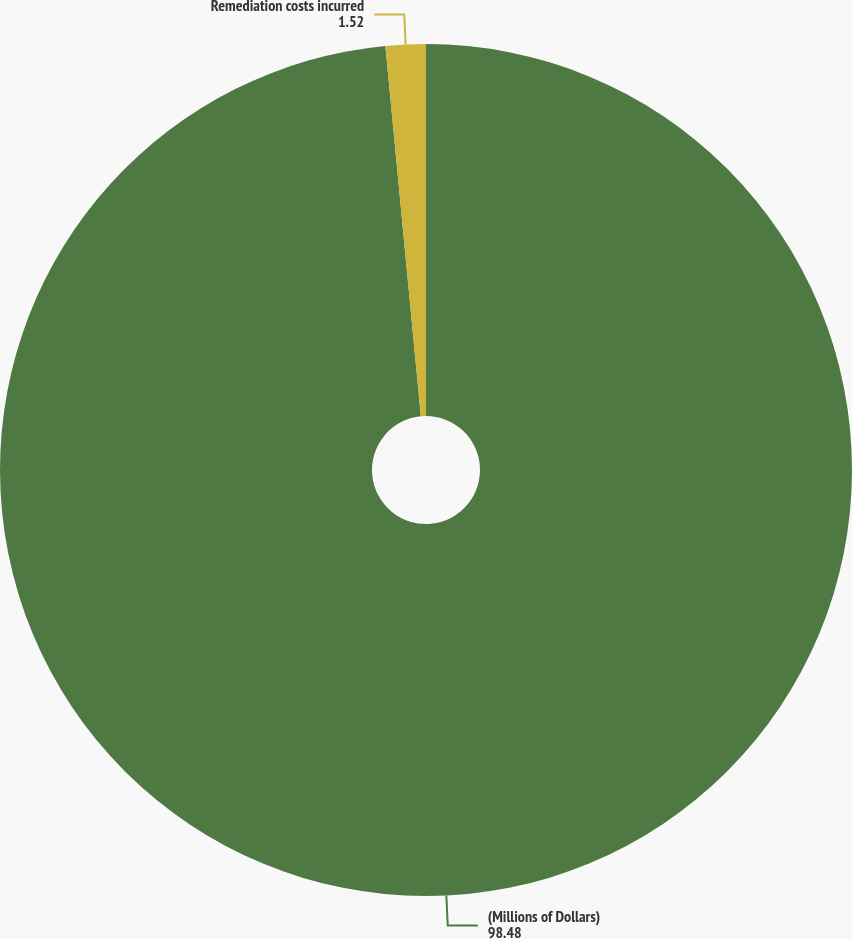Convert chart to OTSL. <chart><loc_0><loc_0><loc_500><loc_500><pie_chart><fcel>(Millions of Dollars)<fcel>Remediation costs incurred<nl><fcel>98.48%<fcel>1.52%<nl></chart> 